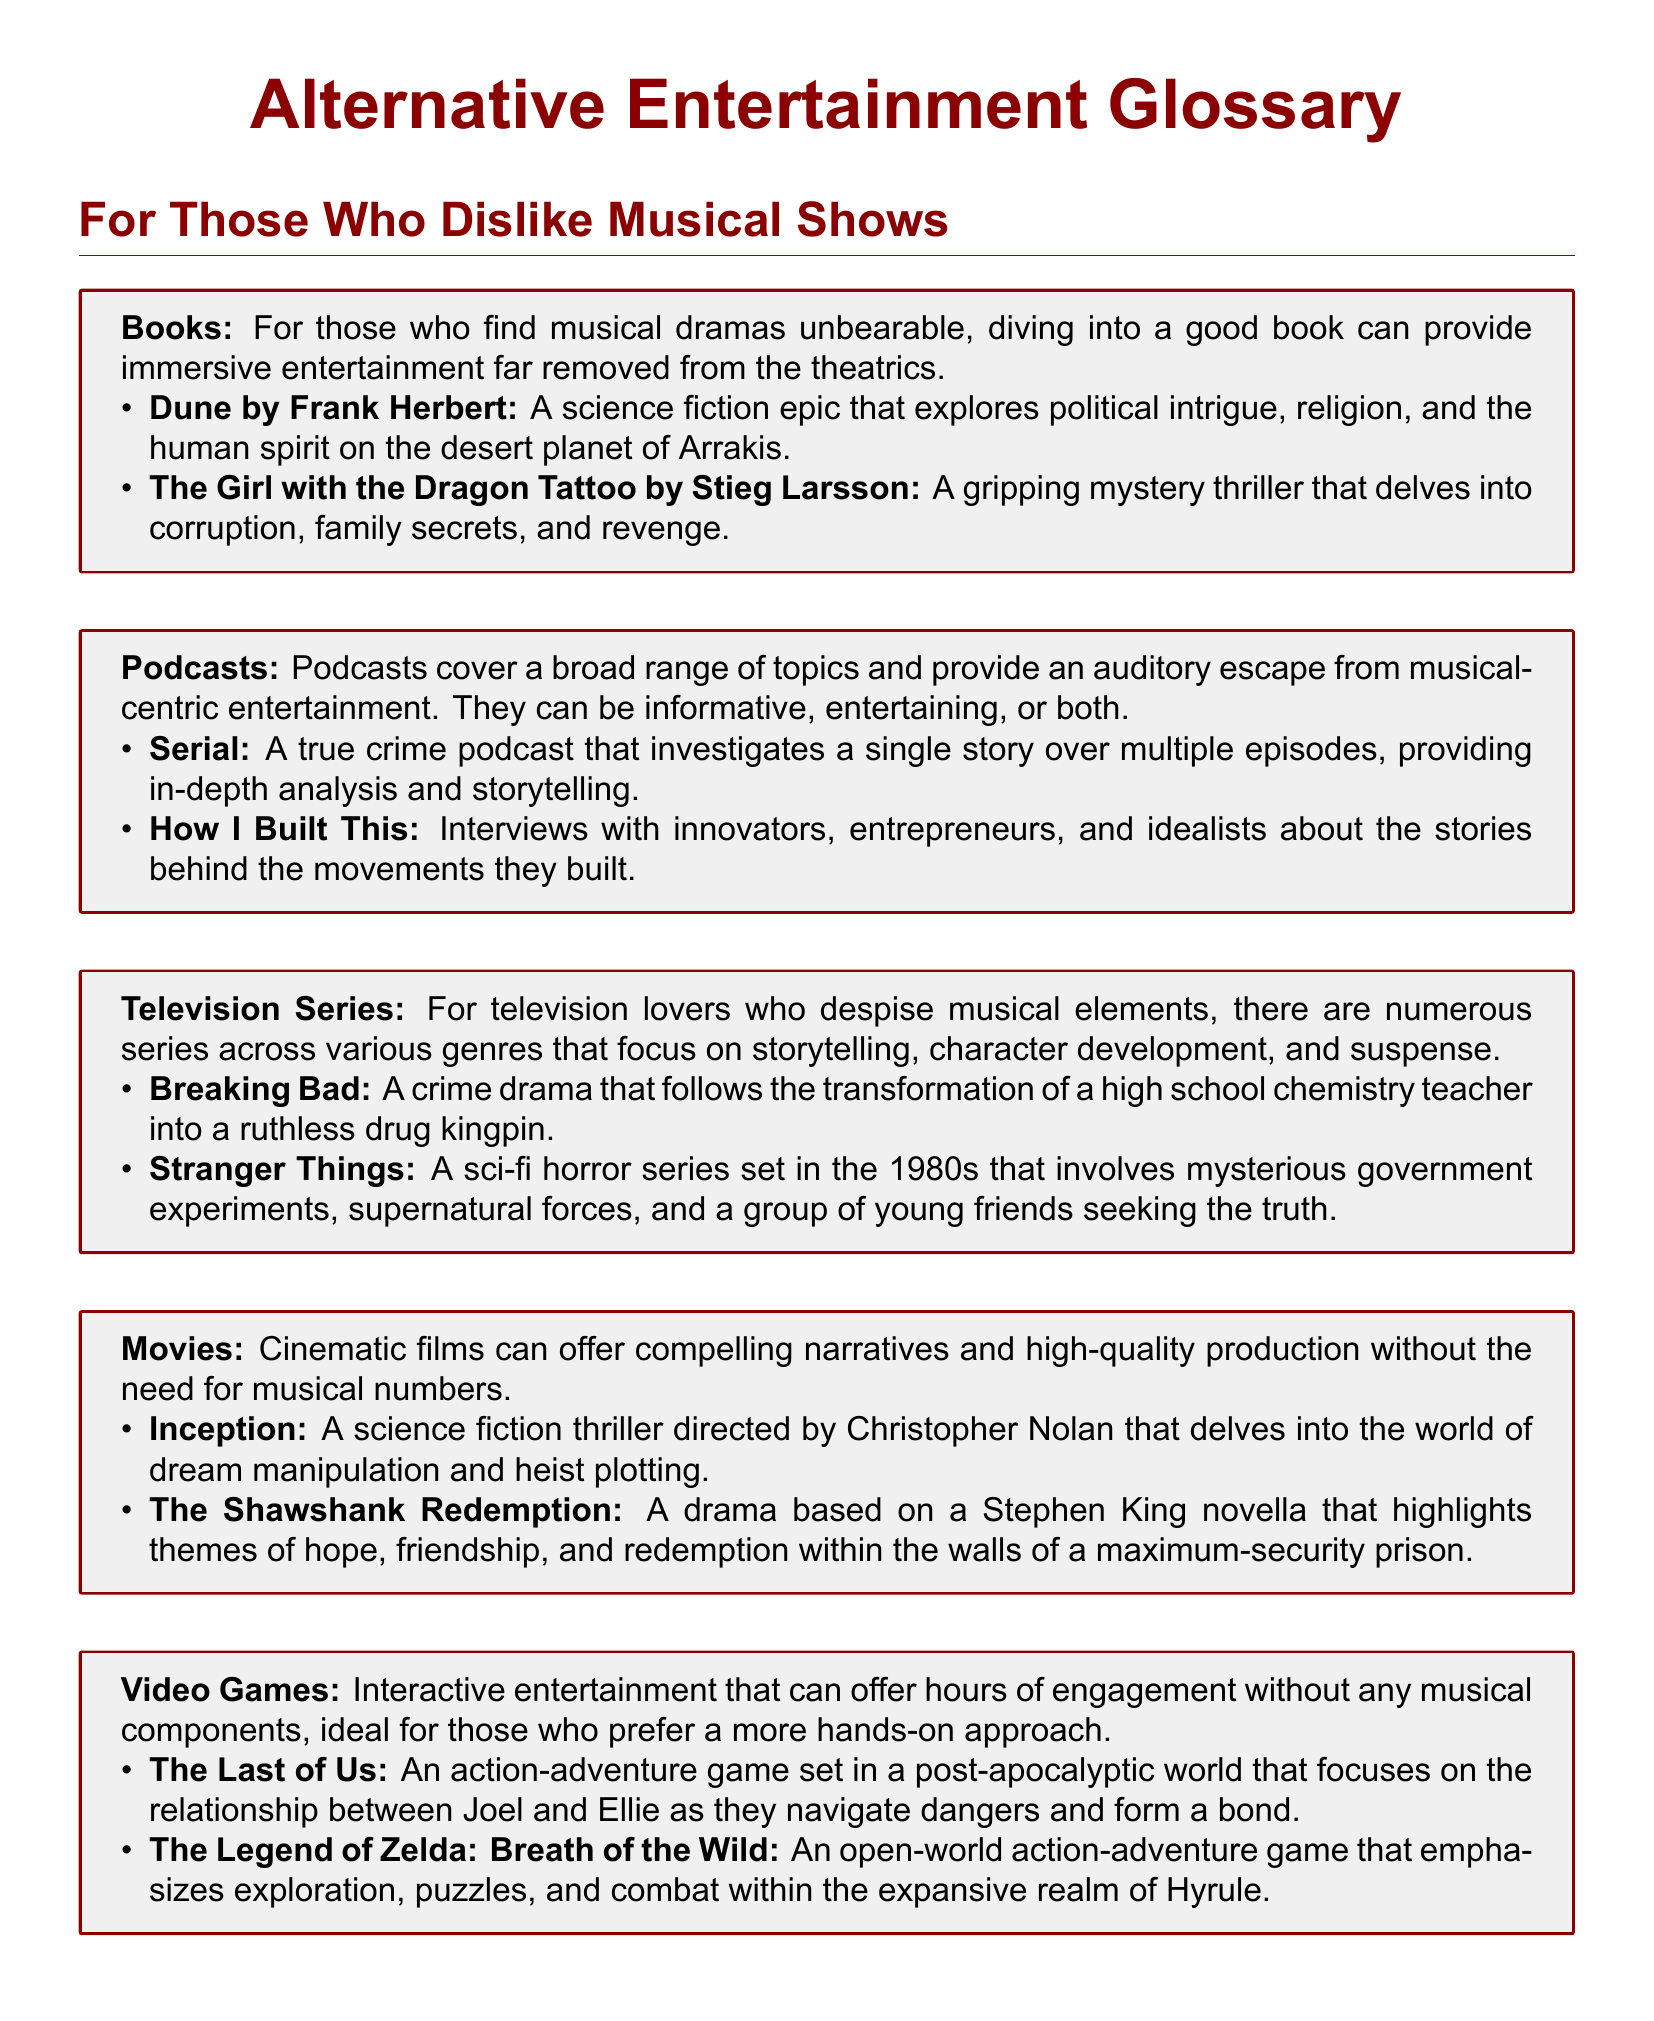what is a recommended book for those who dislike musical shows? The document lists "Dune by Frank Herbert" and "The Girl with the Dragon Tattoo by Stieg Larsson" as recommendations.
Answer: Dune by Frank Herbert which podcast offers a true crime narrative? "Serial" is mentioned in the document as a true crime podcast.
Answer: Serial name a television series with a focus on crime drama. "Breaking Bad" is highlighted as a crime drama series in the document.
Answer: Breaking Bad what genre is "Inception"? The document classifies "Inception" as a science fiction thriller.
Answer: science fiction thriller list one video game recommended in the document. The document provides "The Last of Us" and "The Legend of Zelda: Breath of the Wild" as recommendations.
Answer: The Last of Us how many book recommendations are listed in the glossary? The document contains two book recommendations.
Answer: 2 which series is set in the 1980s? "Stranger Things" is noted for its setting in the 1980s in the document.
Answer: Stranger Things what is the primary theme of "The Shawshank Redemption"? The themes mentioned include hope, friendship, and redemption.
Answer: hope, friendship, redemption which podcast features interviews with entrepreneurs? "How I Built This" is the podcast that features these interviews.
Answer: How I Built This 